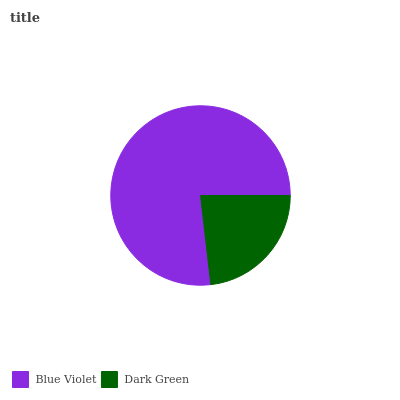Is Dark Green the minimum?
Answer yes or no. Yes. Is Blue Violet the maximum?
Answer yes or no. Yes. Is Dark Green the maximum?
Answer yes or no. No. Is Blue Violet greater than Dark Green?
Answer yes or no. Yes. Is Dark Green less than Blue Violet?
Answer yes or no. Yes. Is Dark Green greater than Blue Violet?
Answer yes or no. No. Is Blue Violet less than Dark Green?
Answer yes or no. No. Is Blue Violet the high median?
Answer yes or no. Yes. Is Dark Green the low median?
Answer yes or no. Yes. Is Dark Green the high median?
Answer yes or no. No. Is Blue Violet the low median?
Answer yes or no. No. 